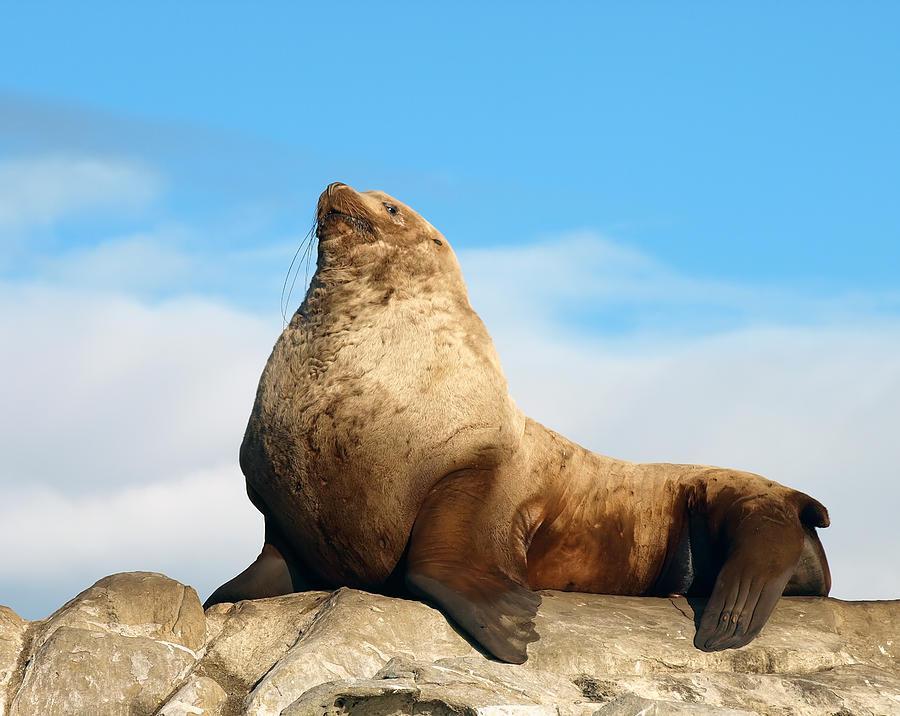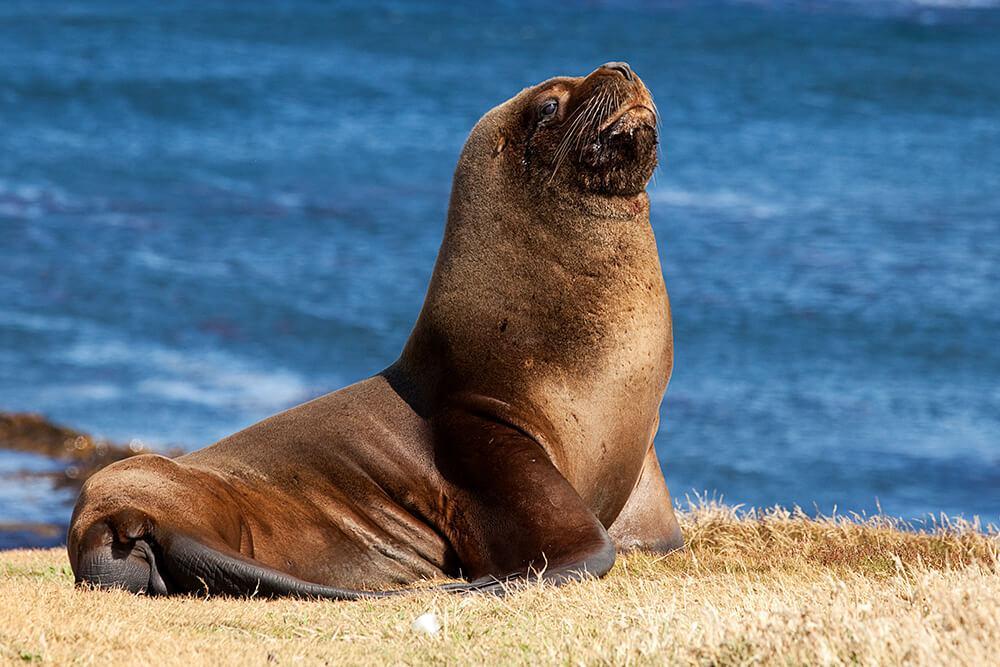The first image is the image on the left, the second image is the image on the right. Evaluate the accuracy of this statement regarding the images: "The left image depicts a young seal which is not black.". Is it true? Answer yes or no. No. The first image is the image on the left, the second image is the image on the right. Analyze the images presented: Is the assertion "The seal in the right image is facing right." valid? Answer yes or no. Yes. 